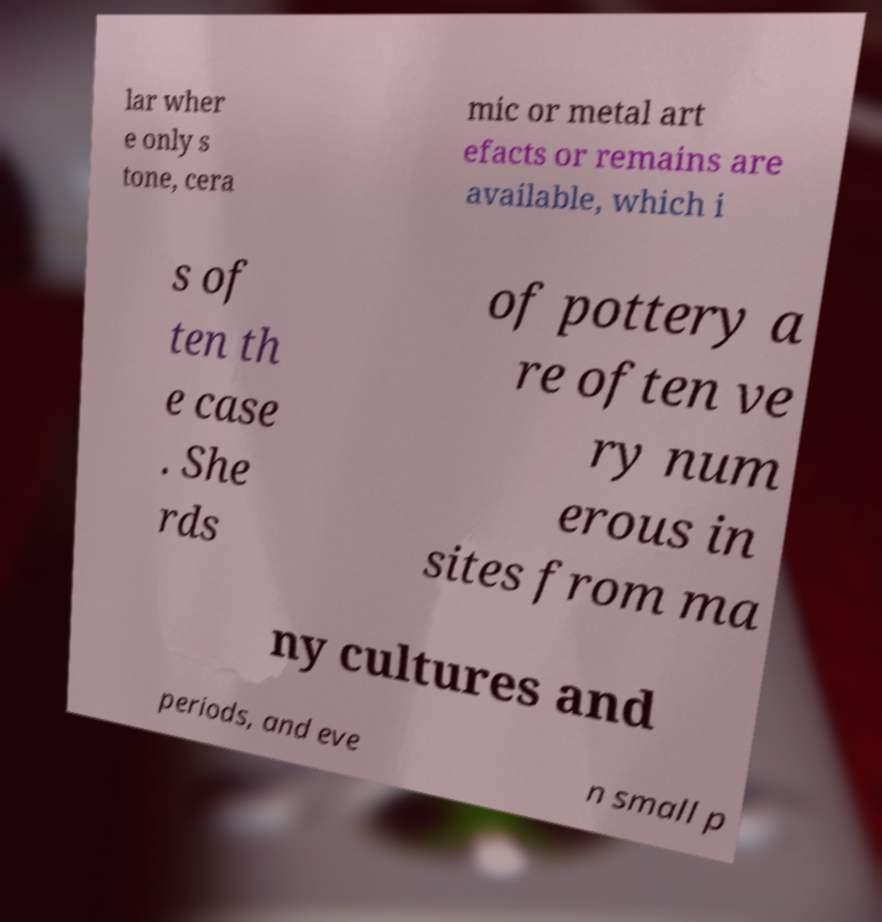I need the written content from this picture converted into text. Can you do that? lar wher e only s tone, cera mic or metal art efacts or remains are available, which i s of ten th e case . She rds of pottery a re often ve ry num erous in sites from ma ny cultures and periods, and eve n small p 